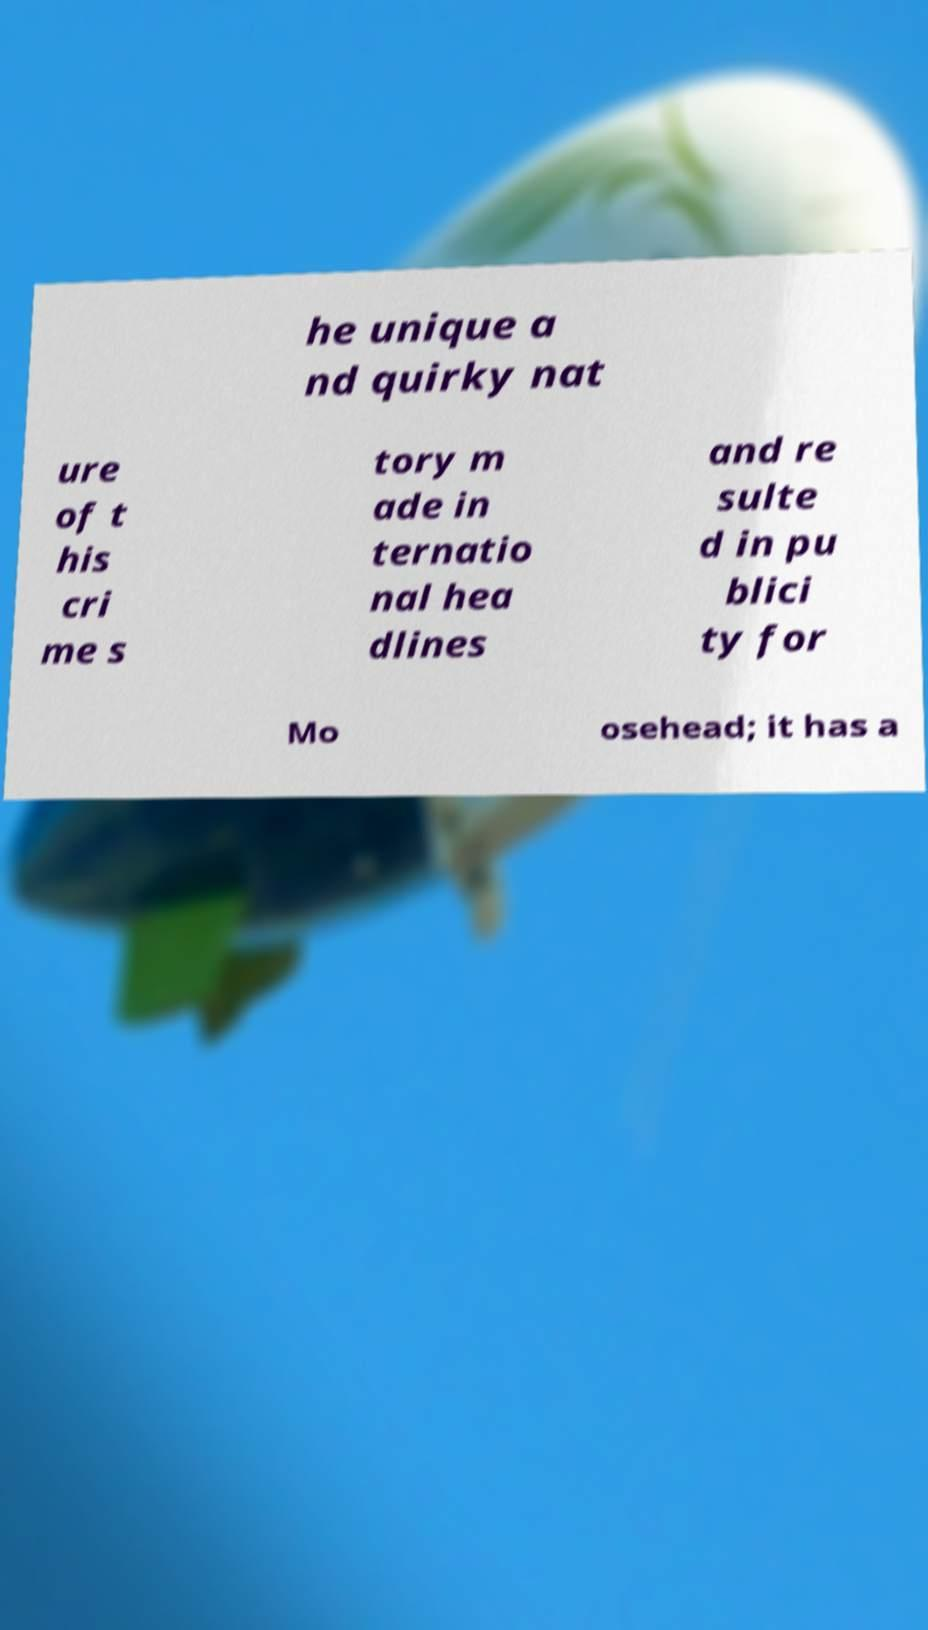Could you extract and type out the text from this image? he unique a nd quirky nat ure of t his cri me s tory m ade in ternatio nal hea dlines and re sulte d in pu blici ty for Mo osehead; it has a 